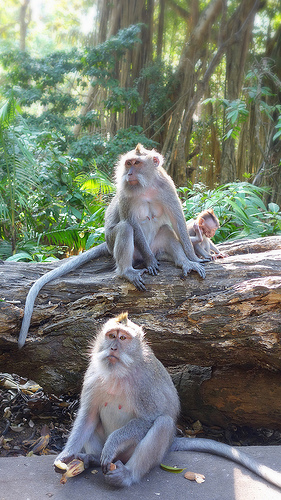<image>
Can you confirm if the monkey is on the tree? Yes. Looking at the image, I can see the monkey is positioned on top of the tree, with the tree providing support. Is there a claws on the baby monkey? No. The claws is not positioned on the baby monkey. They may be near each other, but the claws is not supported by or resting on top of the baby monkey. Is there a monkey on the leaf? No. The monkey is not positioned on the leaf. They may be near each other, but the monkey is not supported by or resting on top of the leaf. 